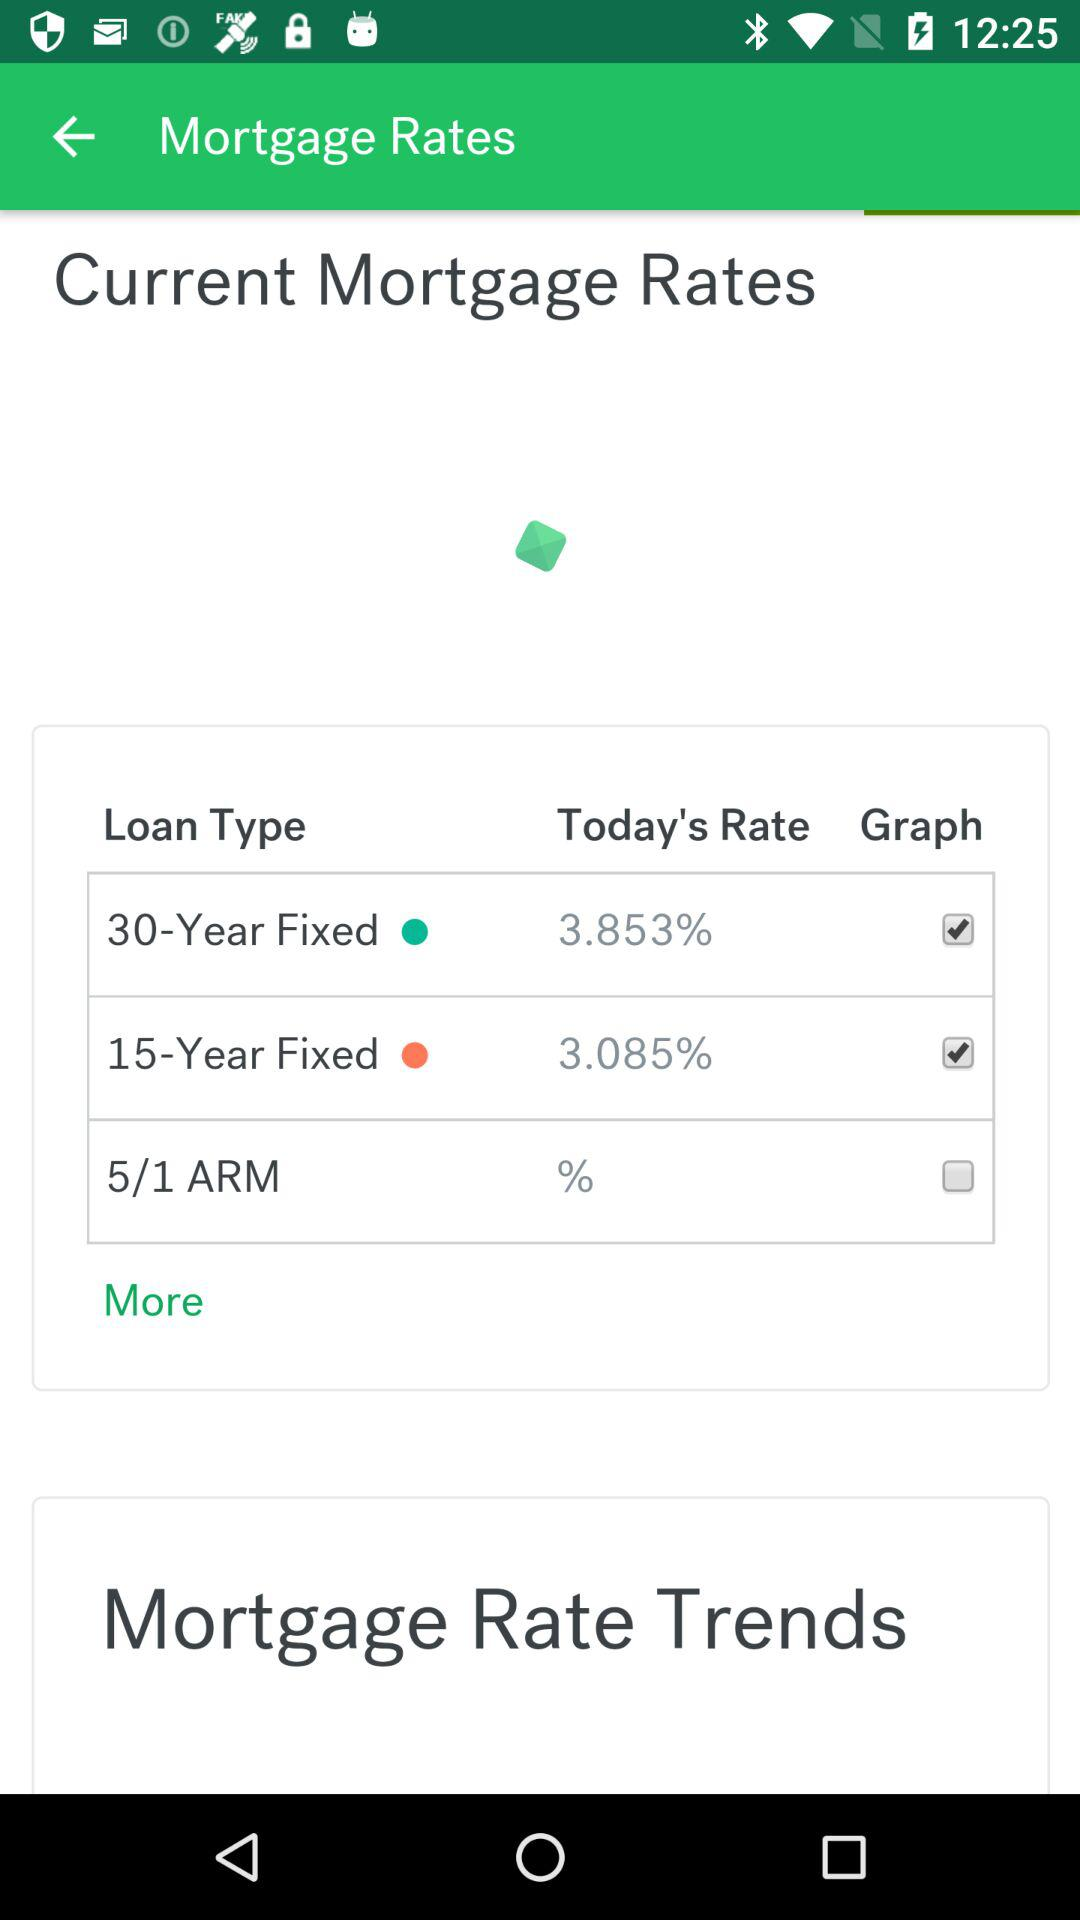What is the status of "Graph" for 5/1 ARM loan type? The status is "off". 